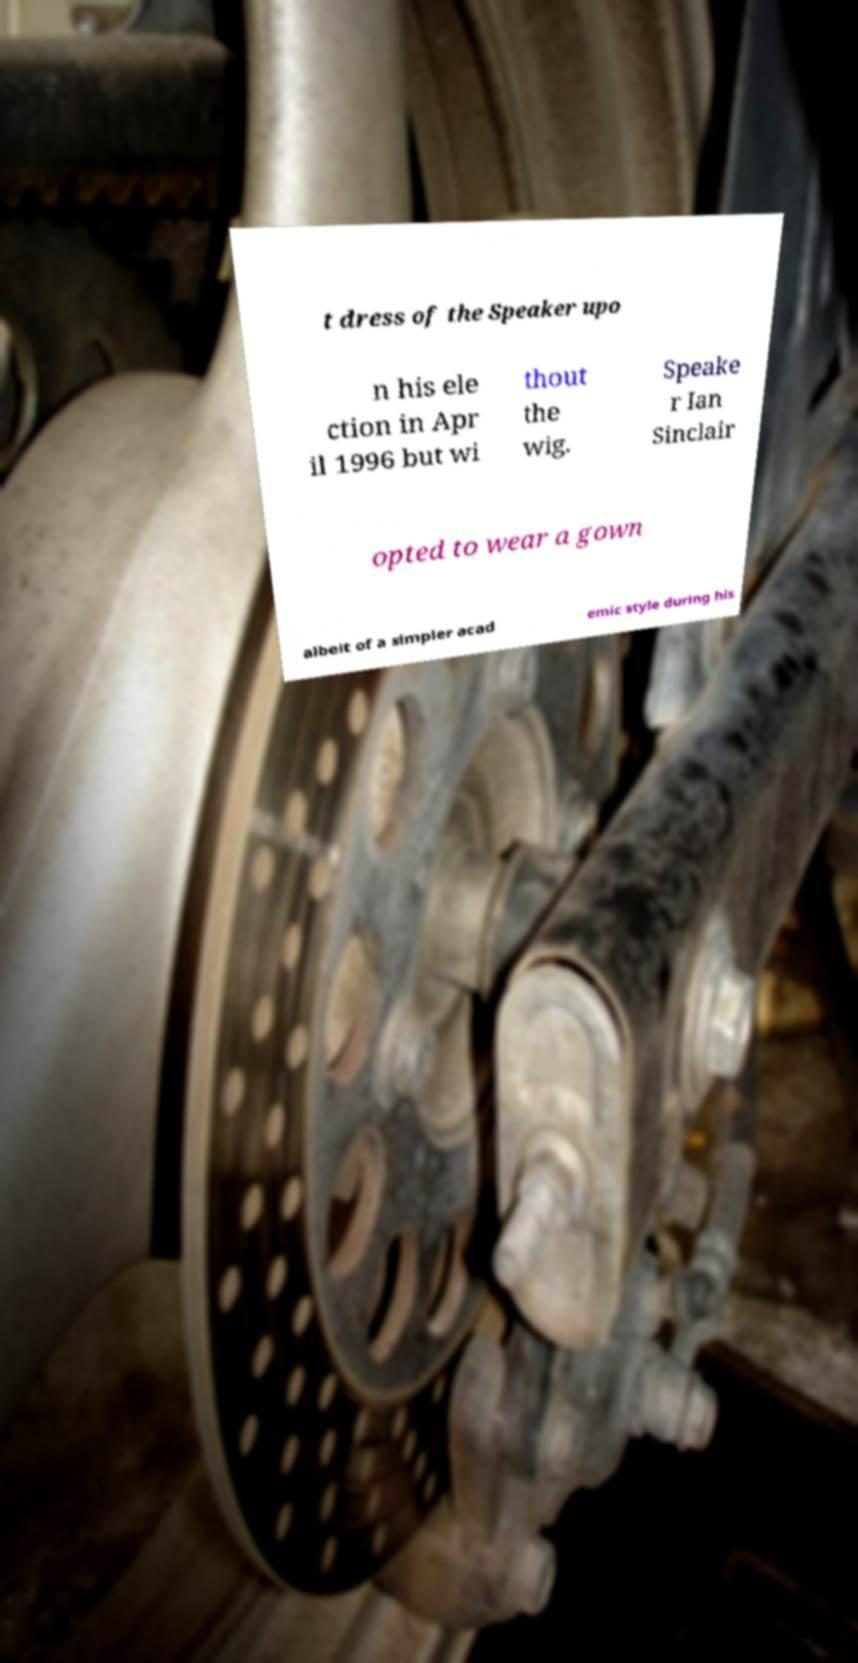Could you assist in decoding the text presented in this image and type it out clearly? t dress of the Speaker upo n his ele ction in Apr il 1996 but wi thout the wig. Speake r Ian Sinclair opted to wear a gown albeit of a simpler acad emic style during his 